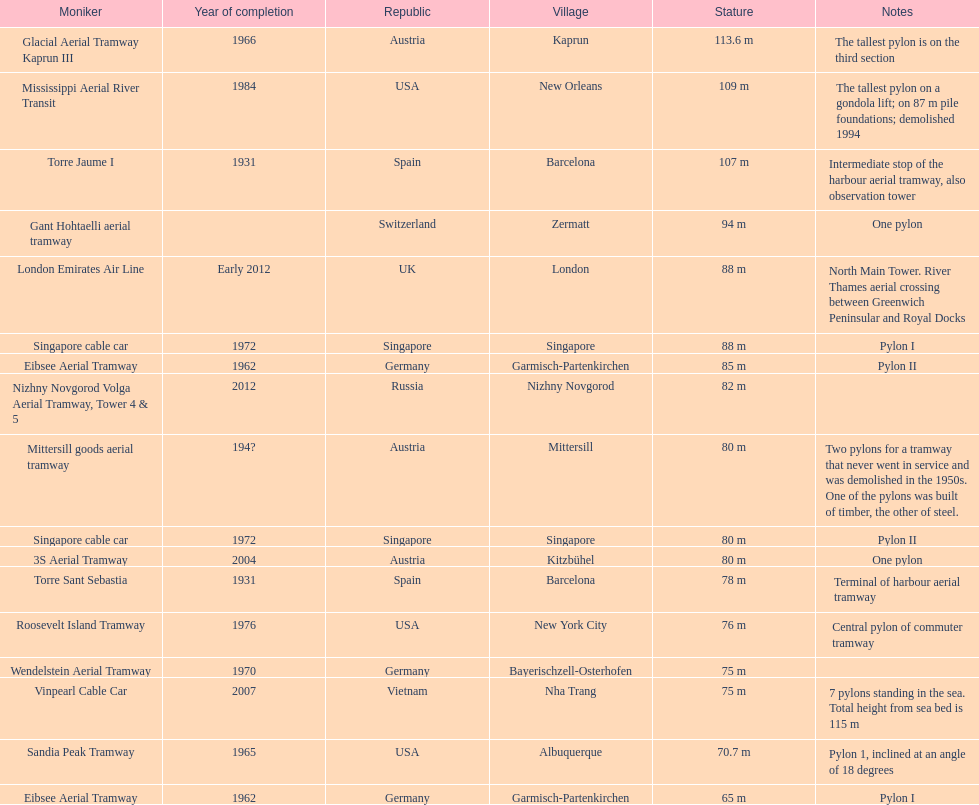What is the total number of pylons listed? 17. 